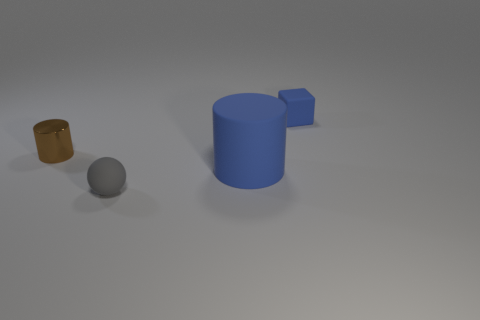What number of cylinders are either matte objects or small brown objects?
Offer a terse response. 2. How many objects are big blue cylinders or small gray rubber things that are in front of the big cylinder?
Provide a succinct answer. 2. Are there any small metallic cylinders?
Your answer should be very brief. Yes. What number of cubes are the same color as the matte cylinder?
Give a very brief answer. 1. There is a cylinder that is the same color as the matte block; what material is it?
Ensure brevity in your answer.  Rubber. What size is the blue thing in front of the object to the right of the blue cylinder?
Your answer should be very brief. Large. Is there another tiny gray sphere that has the same material as the sphere?
Your answer should be very brief. No. What material is the brown cylinder that is the same size as the blue cube?
Give a very brief answer. Metal. Do the tiny matte thing that is behind the tiny gray sphere and the tiny matte object in front of the blue cylinder have the same color?
Keep it short and to the point. No. There is a blue thing that is on the left side of the small blue rubber thing; are there any blue matte cylinders behind it?
Offer a terse response. No. 